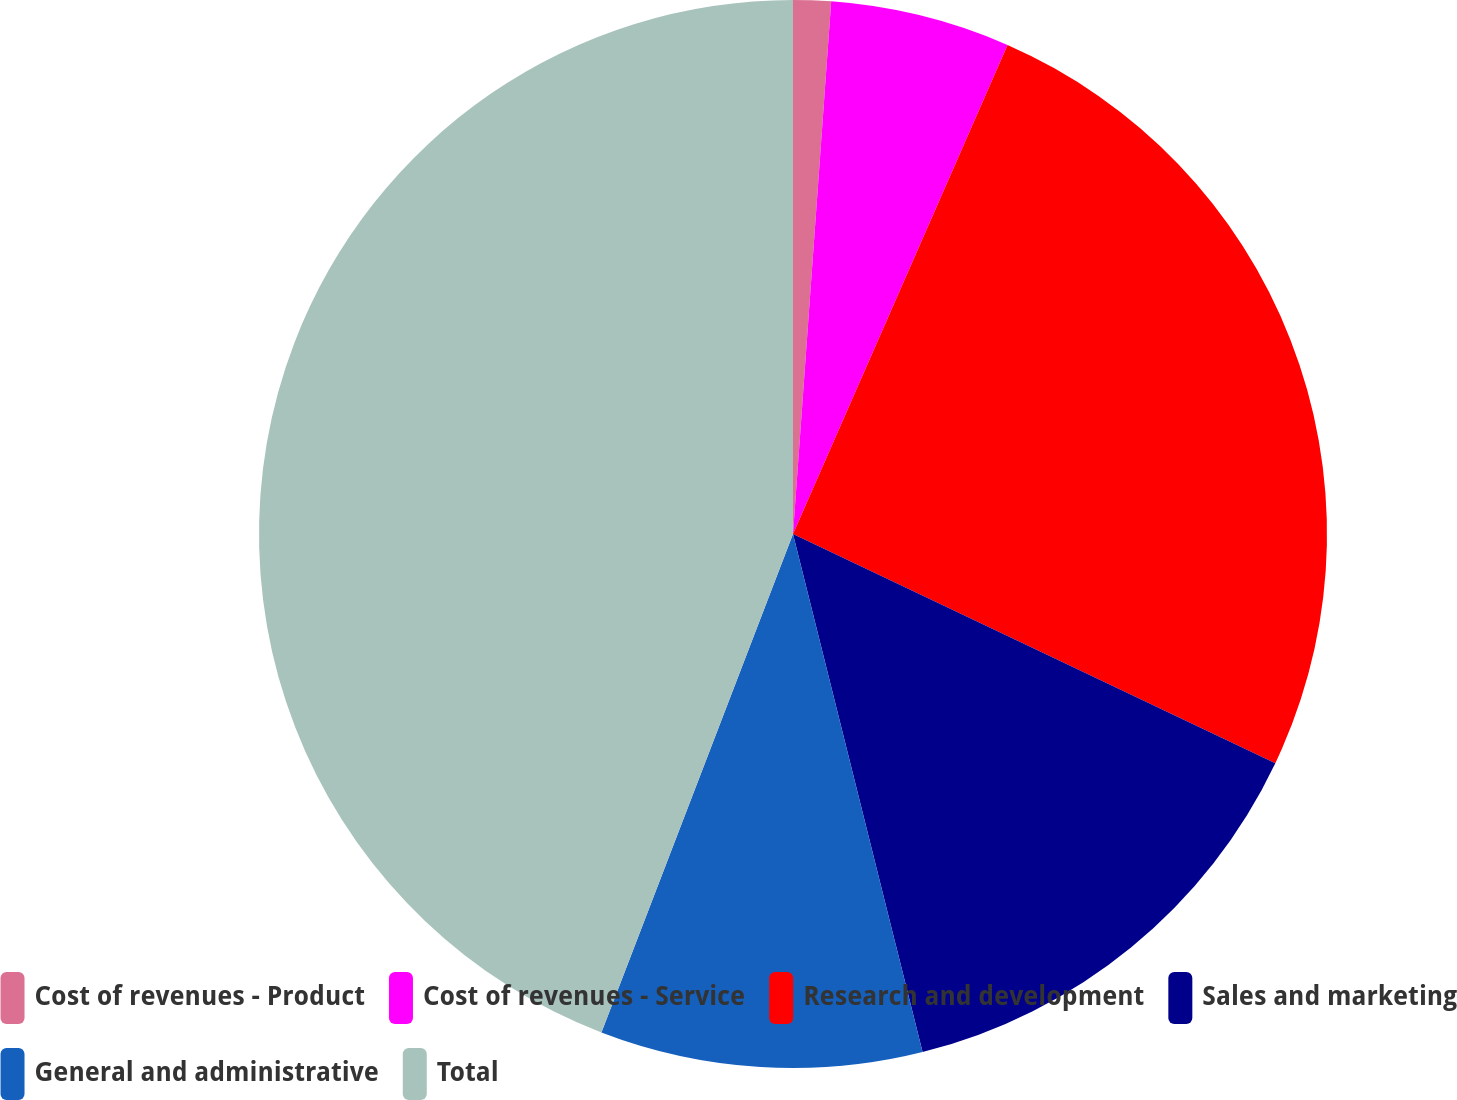<chart> <loc_0><loc_0><loc_500><loc_500><pie_chart><fcel>Cost of revenues - Product<fcel>Cost of revenues - Service<fcel>Research and development<fcel>Sales and marketing<fcel>General and administrative<fcel>Total<nl><fcel>1.14%<fcel>5.44%<fcel>25.48%<fcel>14.04%<fcel>9.74%<fcel>44.16%<nl></chart> 